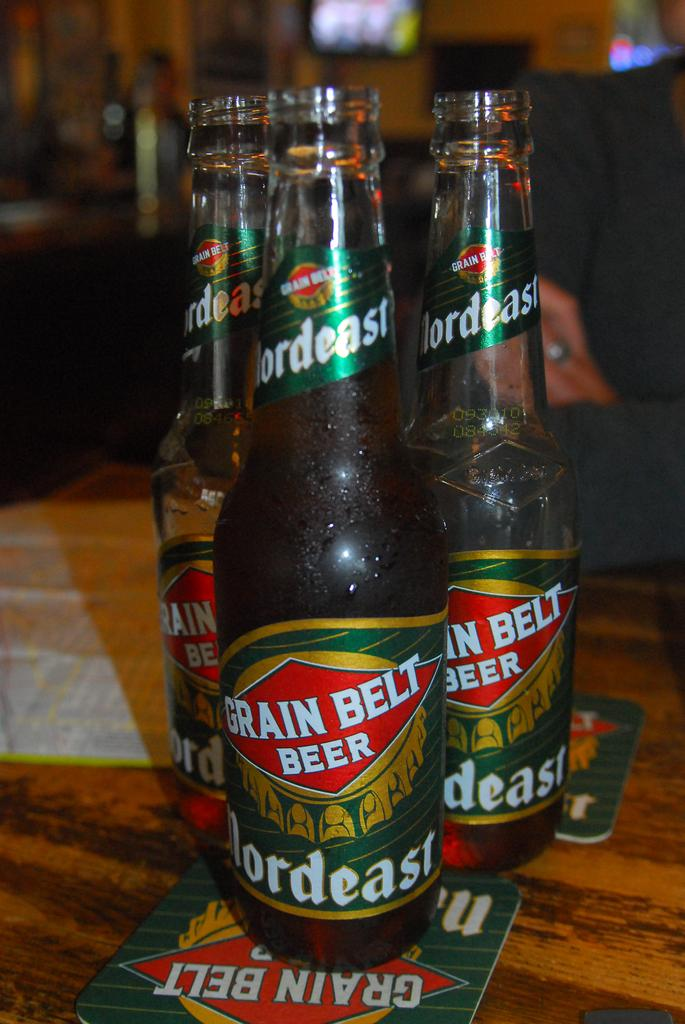<image>
Offer a succinct explanation of the picture presented. Three Grain Belt beer bottle are on a wooden table. 